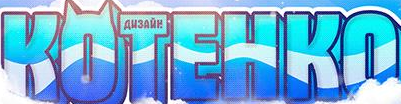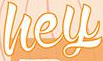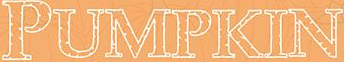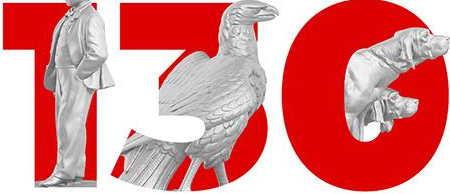What words are shown in these images in order, separated by a semicolon? KOTEHKO; hey; PUMPKIN; 130 